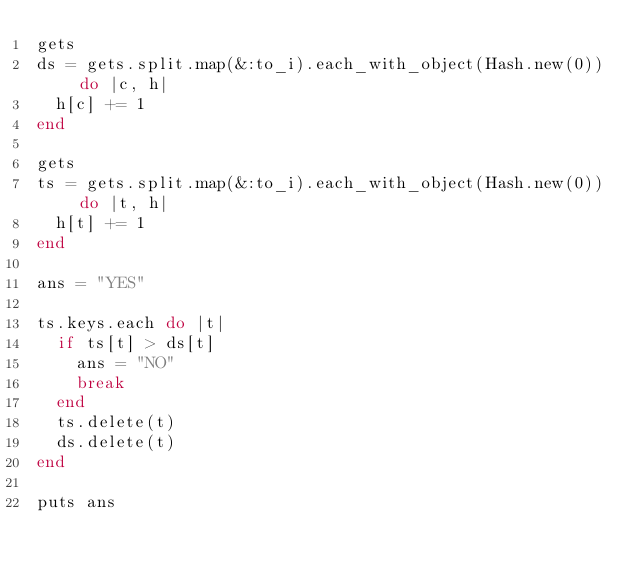Convert code to text. <code><loc_0><loc_0><loc_500><loc_500><_Ruby_>gets
ds = gets.split.map(&:to_i).each_with_object(Hash.new(0)) do |c, h|
  h[c] += 1
end

gets
ts = gets.split.map(&:to_i).each_with_object(Hash.new(0)) do |t, h|
  h[t] += 1
end

ans = "YES"

ts.keys.each do |t|
  if ts[t] > ds[t]
    ans = "NO"
    break
  end
  ts.delete(t)
  ds.delete(t)
end

puts ans
</code> 